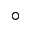Convert formula to latex. <formula><loc_0><loc_0><loc_500><loc_500>^ { \circ }</formula> 